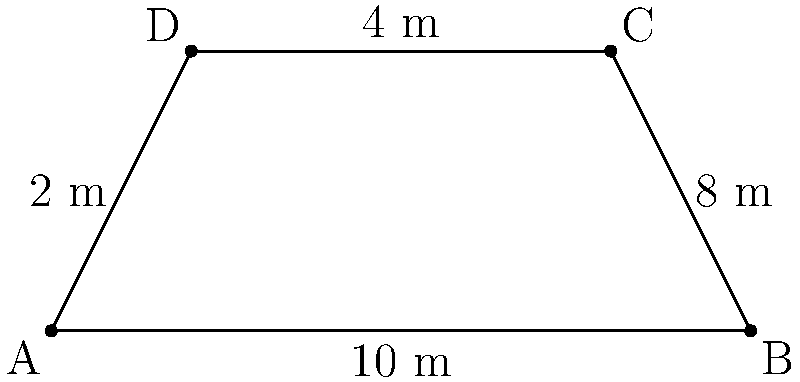At Justin Bieber's latest concert, you noticed a trapezoid-shaped banner displaying his new album cover. The banner's bottom edge measures 10 meters, the top edge is 8 meters, and the height is 4 meters. What is the area of this eye-catching banner? Let's solve this step-by-step:

1) The shape of the banner is a trapezoid. The formula for the area of a trapezoid is:

   $$A = \frac{1}{2}(a+b)h$$

   where $A$ is the area, $a$ and $b$ are the lengths of the parallel sides, and $h$ is the height.

2) From the given information:
   - Bottom edge (a) = 10 meters
   - Top edge (b) = 8 meters
   - Height (h) = 4 meters

3) Let's substitute these values into the formula:

   $$A = \frac{1}{2}(10+8)4$$

4) Simplify inside the parentheses:

   $$A = \frac{1}{2}(18)4$$

5) Multiply:

   $$A = 9 \times 4 = 36$$

Therefore, the area of the Justin Bieber banner is 36 square meters.
Answer: 36 m² 